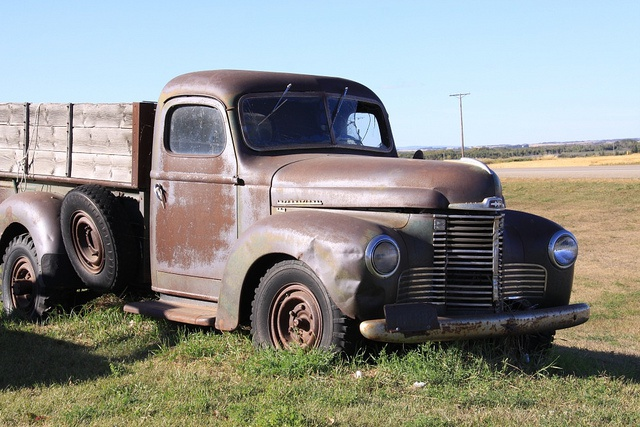Describe the objects in this image and their specific colors. I can see a truck in lightblue, black, darkgray, lightgray, and gray tones in this image. 